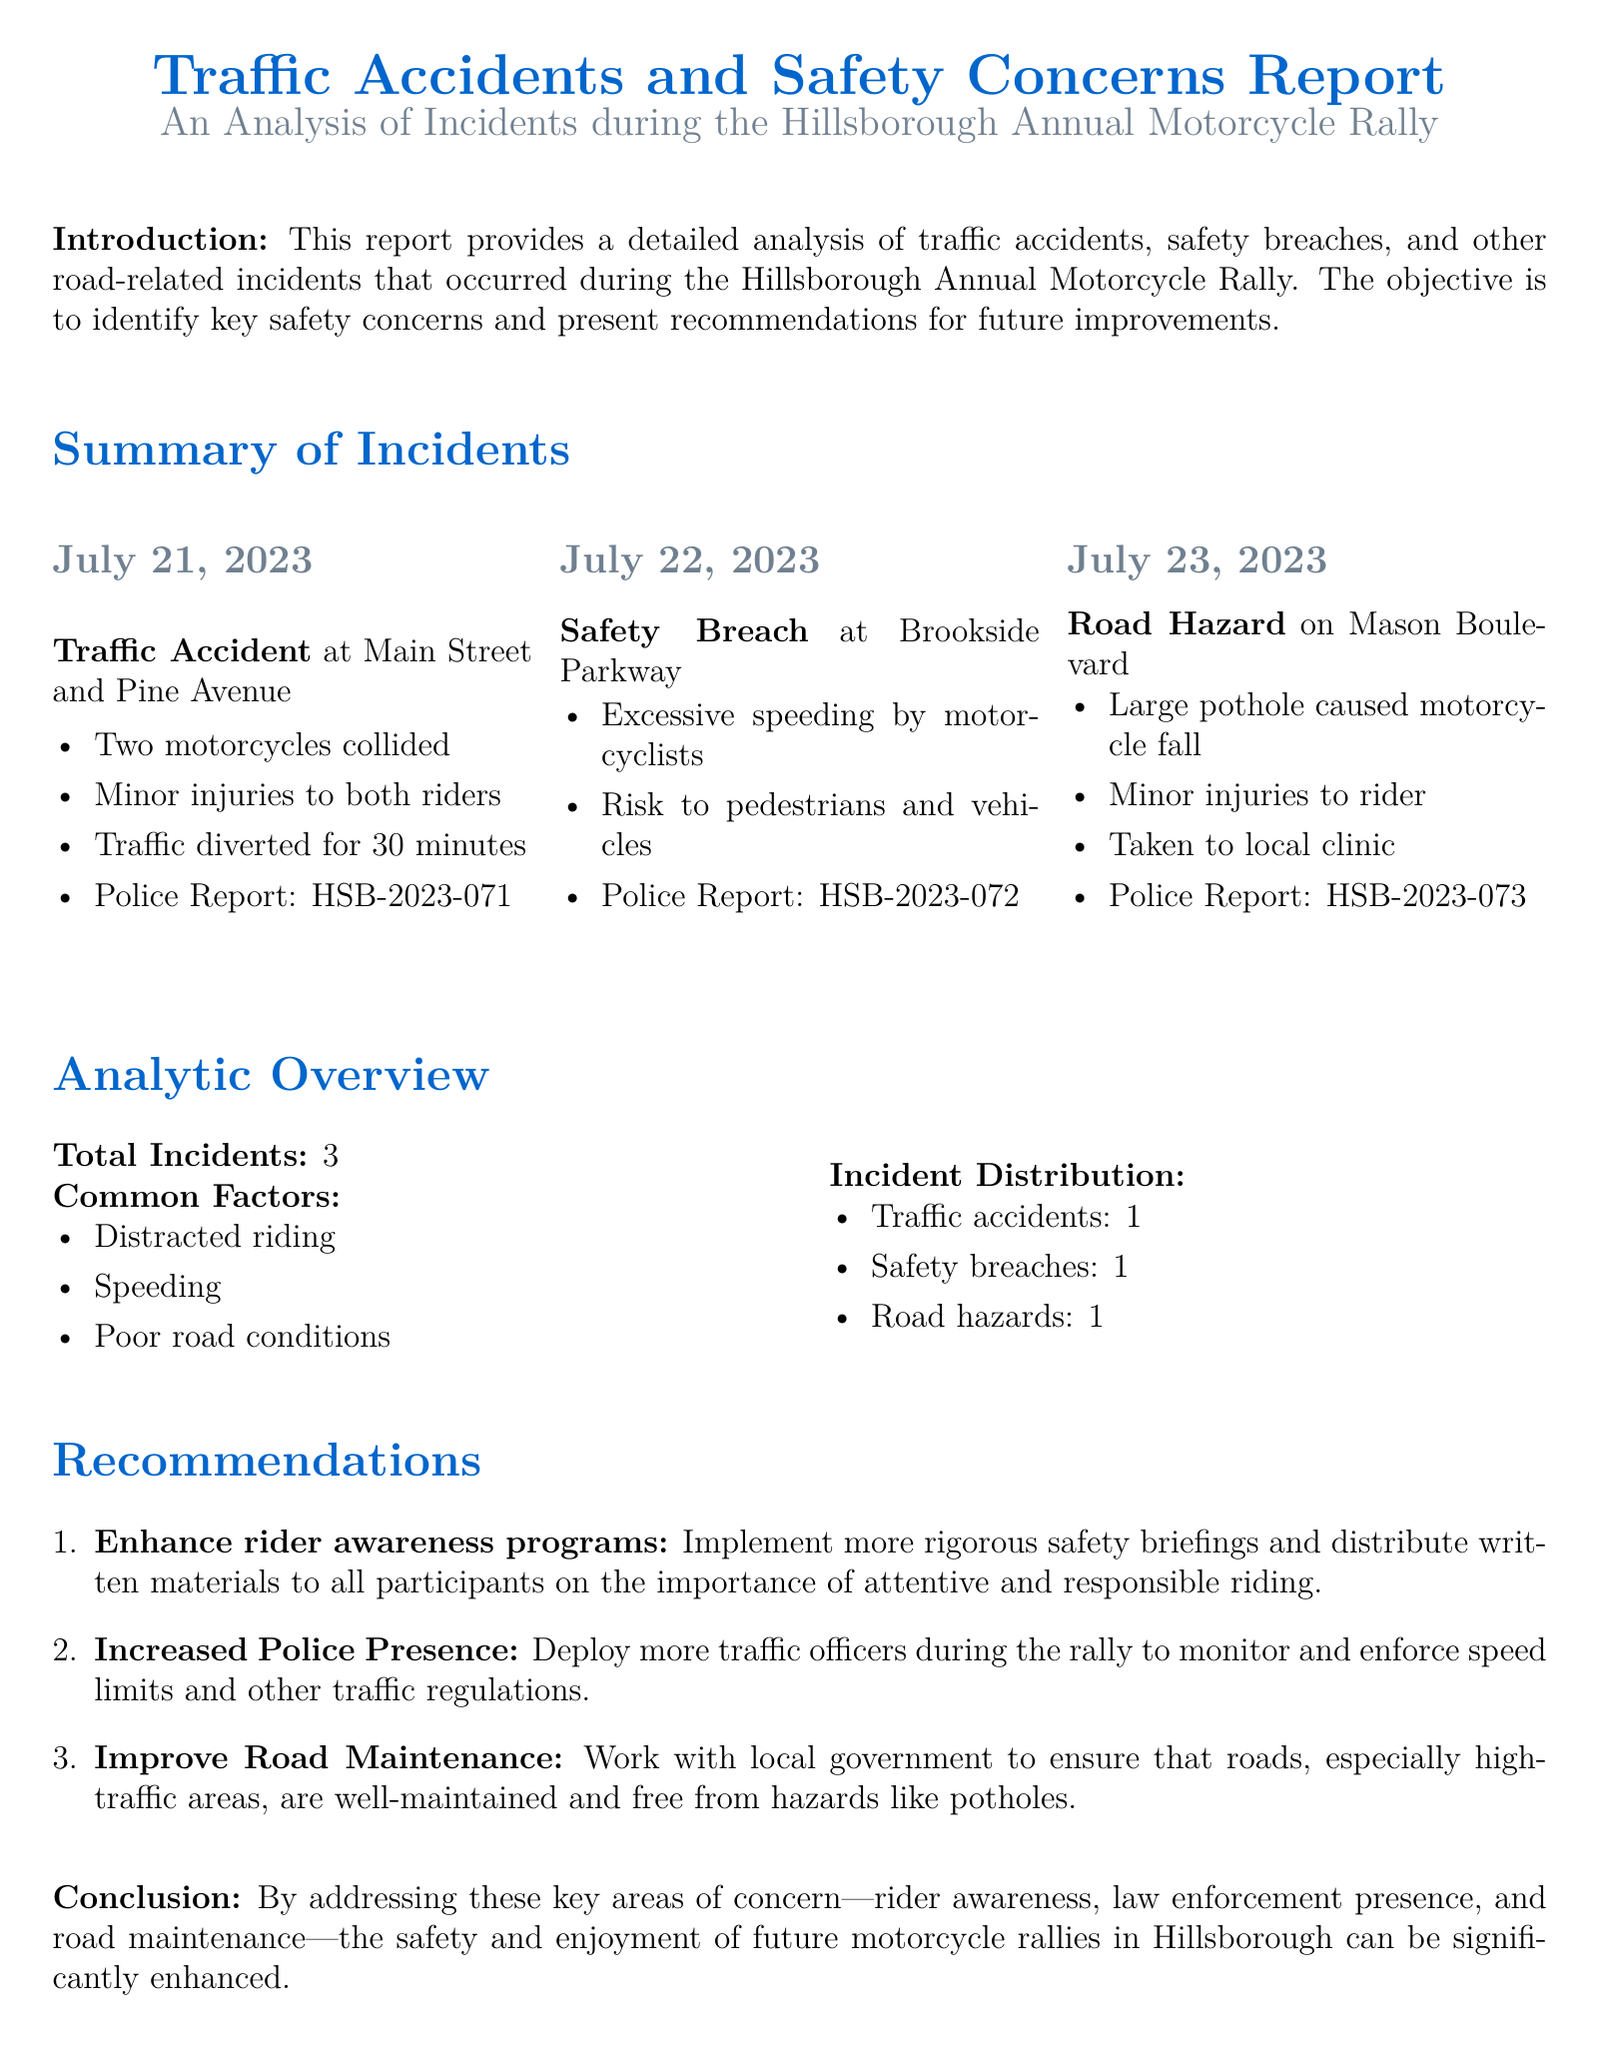What is the date of the first incident reported? The date of the first incident mentioned in the report is July 21, 2023.
Answer: July 21, 2023 How many total incidents occurred during the rally? The summary section of the report states that there were a total of 3 incidents.
Answer: 3 What type of incident occurred on July 22, 2023? The report indicates that a safety breach occurred on July 22, 2023 at Brookside Parkway.
Answer: Safety Breach What were the common factors identified in the report? The document highlights distracted riding, speeding, and poor road conditions as common factors contributing to incidents.
Answer: Distracted riding, speeding, poor road conditions What is one recommendation made for future improvements? The report recommends enhancing rider awareness programs to improve safety.
Answer: Enhance rider awareness programs How long was traffic diverted during the accident at Main Street and Pine Avenue? The report specifies that traffic was diverted for 30 minutes due to the incident.
Answer: 30 minutes Which street had a road hazard that caused a motorcycle fall? The report details that the road hazard on Mason Boulevard caused the motorcycle fall.
Answer: Mason Boulevard What police report number corresponds to the road hazard incident? According to the report, the police report number for the road hazard incident is HSB-2023-073.
Answer: HSB-2023-073 